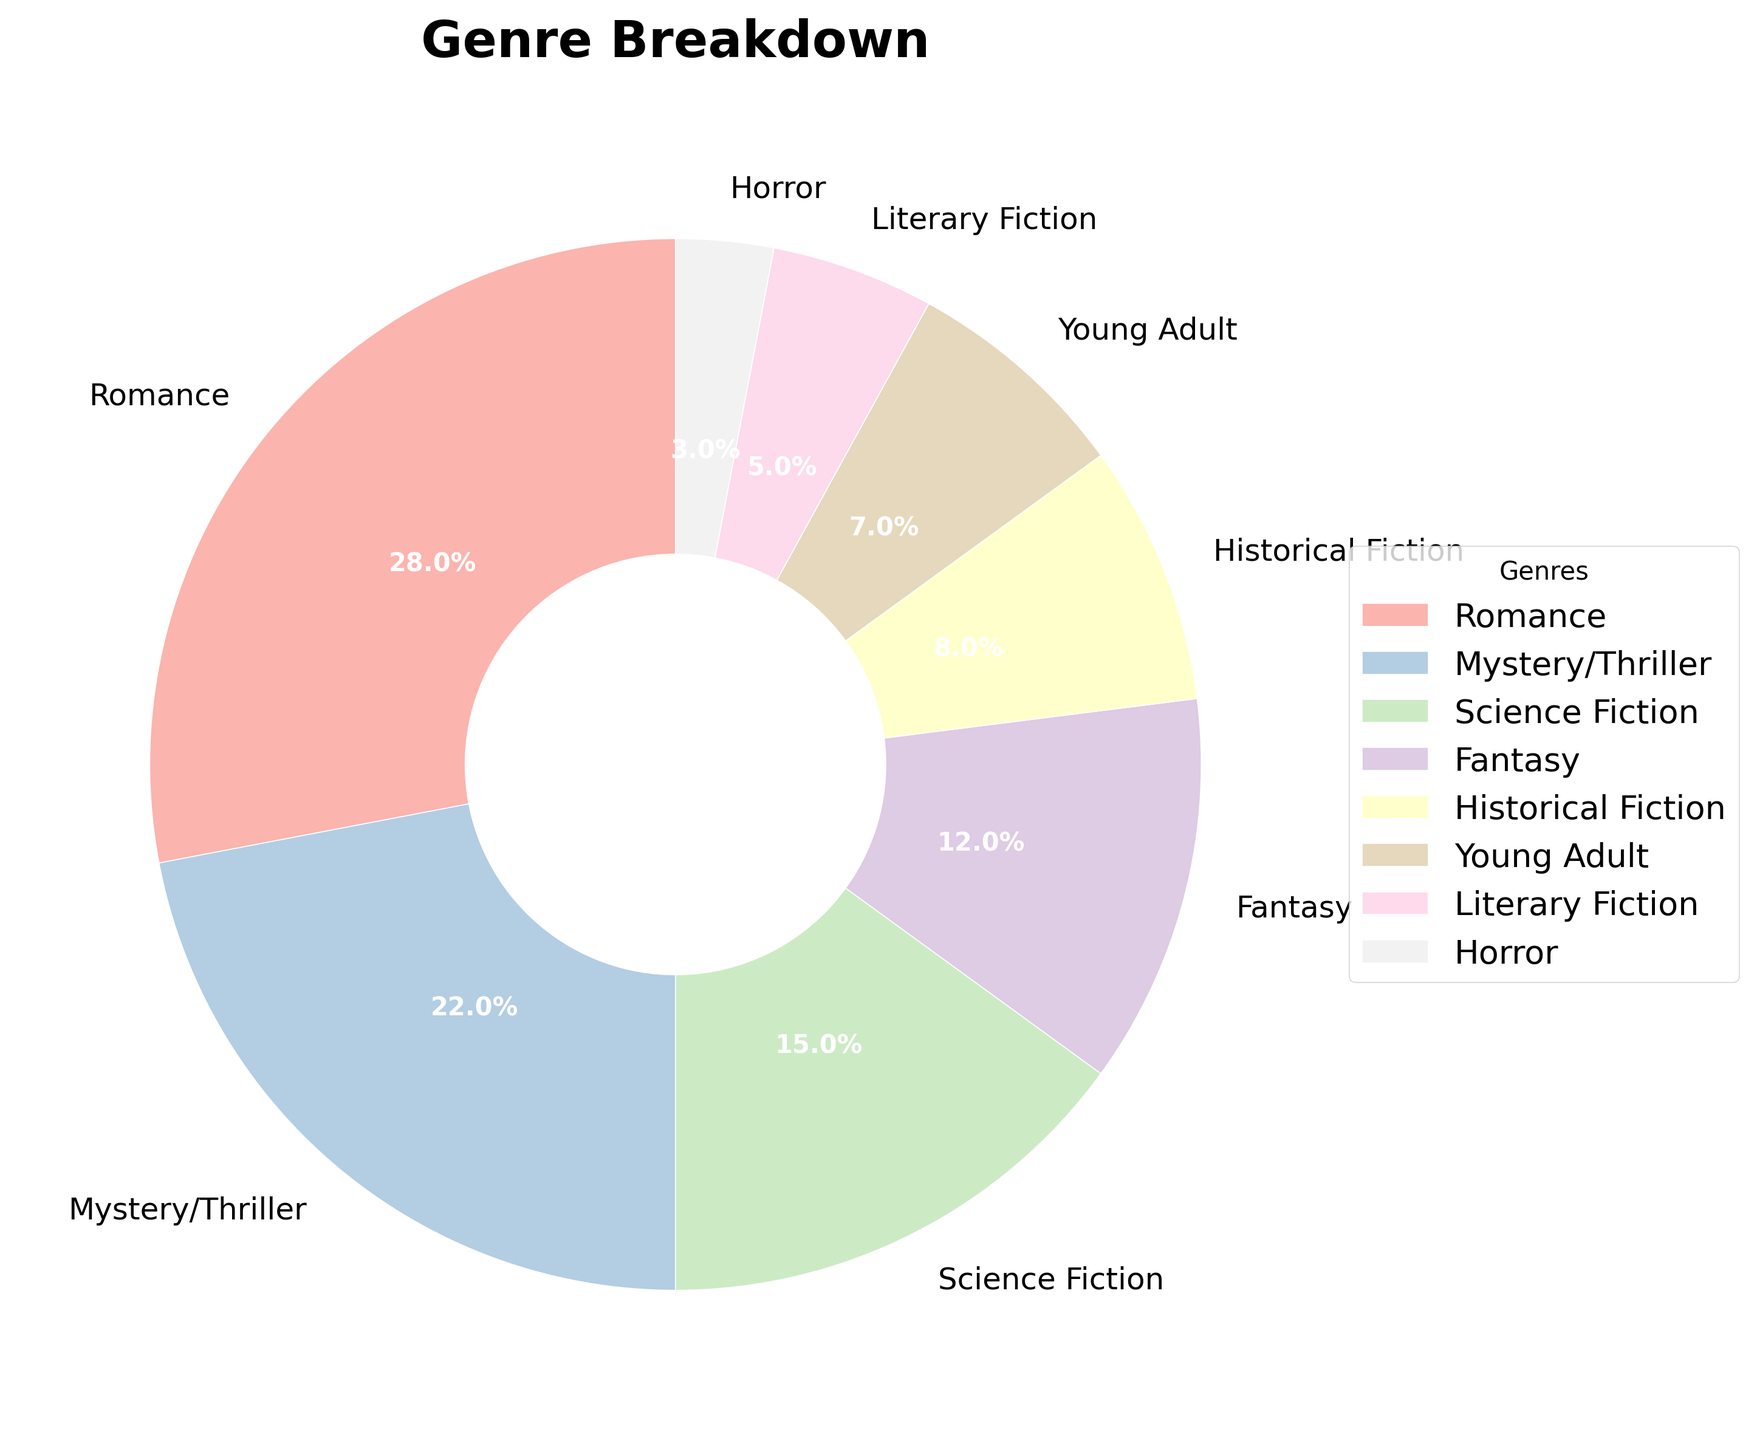Which genre has the highest percentage? The pie chart shows the genre breakdown with their respective percentages. By looking at the largest slice, we can see that Romance has the highest percentage.
Answer: Romance Which genre has a lower percentage, Horror or Young Adult? By comparing the slices for Horror and Young Adult, it is evident that Horror has a smaller slice, indicating a lower percentage.
Answer: Horror What is the combined percentage of Romance and Mystery/Thriller? To find the combined percentage of Romance and Mystery/Thriller, we sum the percentages of both genres: 28% (Romance) + 22% (Mystery/Thriller) = 50%.
Answer: 50% Are there any genres that have the same percentage? By examining the pie chart, no two genres have slices of the same size, indicating no identical percentages.
Answer: No Which genre has a percentage close to that of Science Fiction? Science Fiction has a percentage of 15%. The closest percentage to this is Fantasy with 12%.
Answer: Fantasy What is the difference in percentage between Fantasy and Historical Fiction? To find the difference, subtract the percentage of Historical Fiction from that of Fantasy: 12% (Fantasy) - 8% (Historical Fiction) = 4%.
Answer: 4% What is the average percentage of Historical Fiction, Young Adult, and Literary Fiction? To find the average, add their percentages and divide by the number of genres. (8% + 7% + 5%) / 3 = 20% / 3 ≈ 6.67%.
Answer: 6.67% Which genre's percentage is twice that of Horror? Horror has a percentage of 3%. The genre closest to twice this percentage is Young Adult with 7%.
Answer: Young Adult What is the median percentage of all genres? To find the median, list the percentages in ascending order: 3%, 5%, 7%, 8%, 12%, 15%, 22%, 28%. The median is the average of the two middle values: (8% + 12%) / 2 = 10%.
Answer: 10% Identify the genres whose combined percentages form slightly more than half of the entire chart. Summing the largest percentages until just over half (50%): Romance (28%) + Mystery/Thriller (22%) = 50%. This is exactly half, so slightly more needs adding another genre's smallest percentage: 50% + Science Fiction (15%); so Romance, Mystery/Thriller, Science Fiction together = 65%.
Answer: Romance, Mystery/Thriller, Science Fiction 